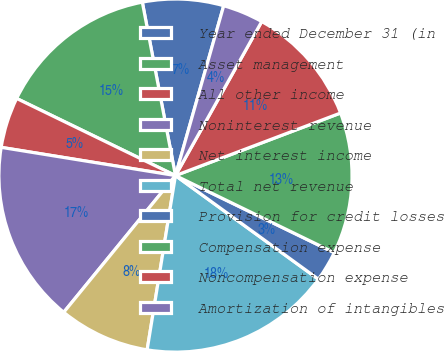Convert chart to OTSL. <chart><loc_0><loc_0><loc_500><loc_500><pie_chart><fcel>Year ended December 31 (in<fcel>Asset management<fcel>All other income<fcel>Noninterest revenue<fcel>Net interest income<fcel>Total net revenue<fcel>Provision for credit losses<fcel>Compensation expense<fcel>Noncompensation expense<fcel>Amortization of intangibles<nl><fcel>7.41%<fcel>14.8%<fcel>4.64%<fcel>16.65%<fcel>8.34%<fcel>17.58%<fcel>2.79%<fcel>12.96%<fcel>11.11%<fcel>3.72%<nl></chart> 